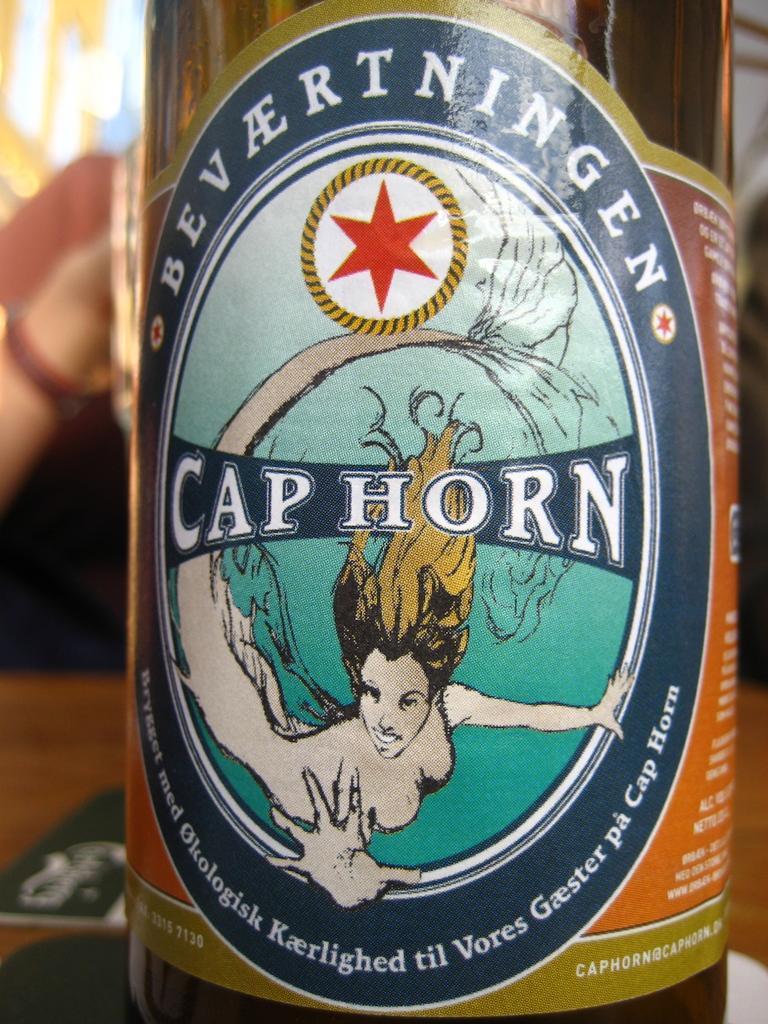Describe this image in one or two sentences. In this image we can see the label of a bottle. On the label there is an image of a lady and some text on it. 